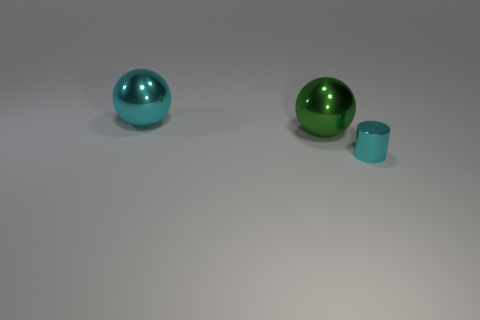Add 3 cyan metal objects. How many objects exist? 6 Subtract all spheres. How many objects are left? 1 Add 3 big shiny objects. How many big shiny objects are left? 5 Add 3 shiny cylinders. How many shiny cylinders exist? 4 Subtract 0 red spheres. How many objects are left? 3 Subtract all small cyan metal cubes. Subtract all metallic cylinders. How many objects are left? 2 